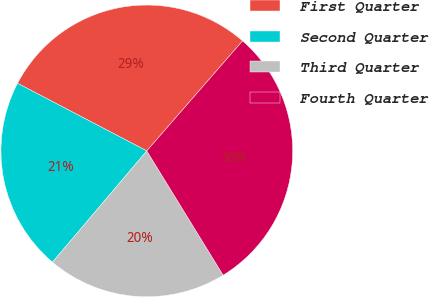Convert chart. <chart><loc_0><loc_0><loc_500><loc_500><pie_chart><fcel>First Quarter<fcel>Second Quarter<fcel>Third Quarter<fcel>Fourth Quarter<nl><fcel>28.73%<fcel>21.48%<fcel>19.96%<fcel>29.83%<nl></chart> 